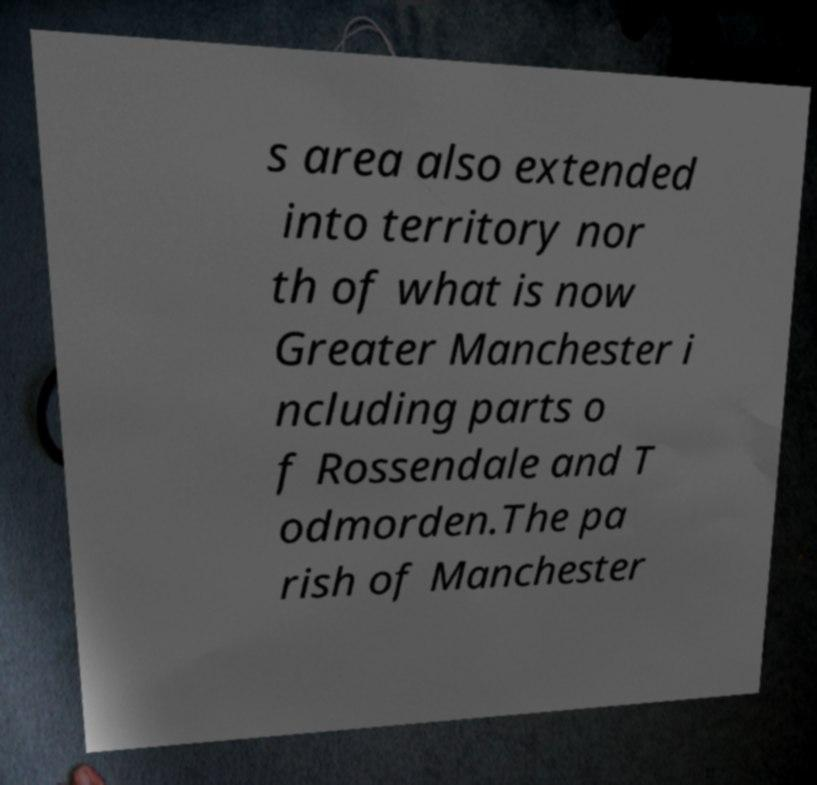I need the written content from this picture converted into text. Can you do that? s area also extended into territory nor th of what is now Greater Manchester i ncluding parts o f Rossendale and T odmorden.The pa rish of Manchester 